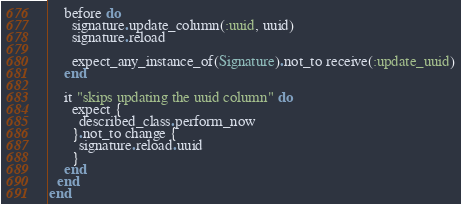<code> <loc_0><loc_0><loc_500><loc_500><_Ruby_>
    before do
      signature.update_column(:uuid, uuid)
      signature.reload

      expect_any_instance_of(Signature).not_to receive(:update_uuid)
    end

    it "skips updating the uuid column" do
      expect {
        described_class.perform_now
      }.not_to change {
        signature.reload.uuid
      }
    end
  end
end
</code> 